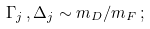Convert formula to latex. <formula><loc_0><loc_0><loc_500><loc_500>\Gamma _ { j } \, , \Delta _ { j } \sim m _ { D } / m _ { F } \, ;</formula> 